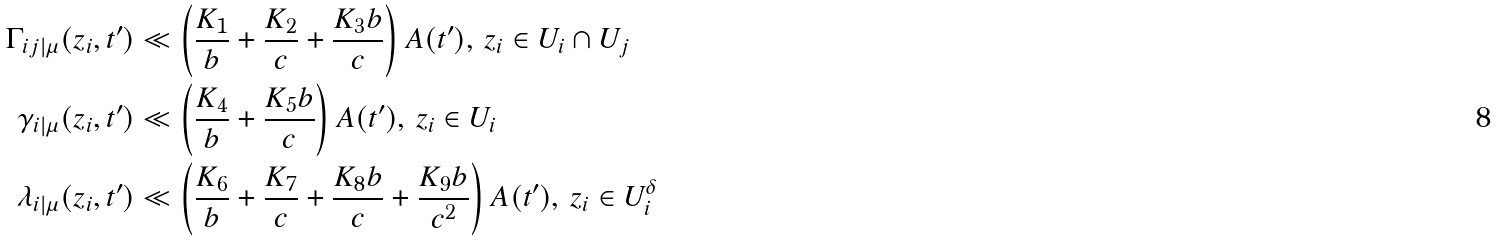<formula> <loc_0><loc_0><loc_500><loc_500>\Gamma _ { i j | \mu } ( z _ { i } , t ^ { \prime } ) & \ll \left ( \frac { K _ { 1 } } { b } + \frac { K _ { 2 } } { c } + \frac { K _ { 3 } b } { c } \right ) A ( t ^ { \prime } ) , \, z _ { i } \in U _ { i } \cap U _ { j } \\ \gamma _ { i | \mu } ( z _ { i } , t ^ { \prime } ) & \ll \left ( \frac { K _ { 4 } } { b } + \frac { K _ { 5 } b } { c } \right ) A ( t ^ { \prime } ) , \, z _ { i } \in U _ { i } \\ \lambda _ { i | \mu } ( z _ { i } , t ^ { \prime } ) & \ll \left ( \frac { K _ { 6 } } { b } + \frac { K _ { 7 } } { c } + \frac { K _ { 8 } b } { c } + \frac { K _ { 9 } b } { c ^ { 2 } } \right ) A ( t ^ { \prime } ) , \, z _ { i } \in U _ { i } ^ { \delta }</formula> 